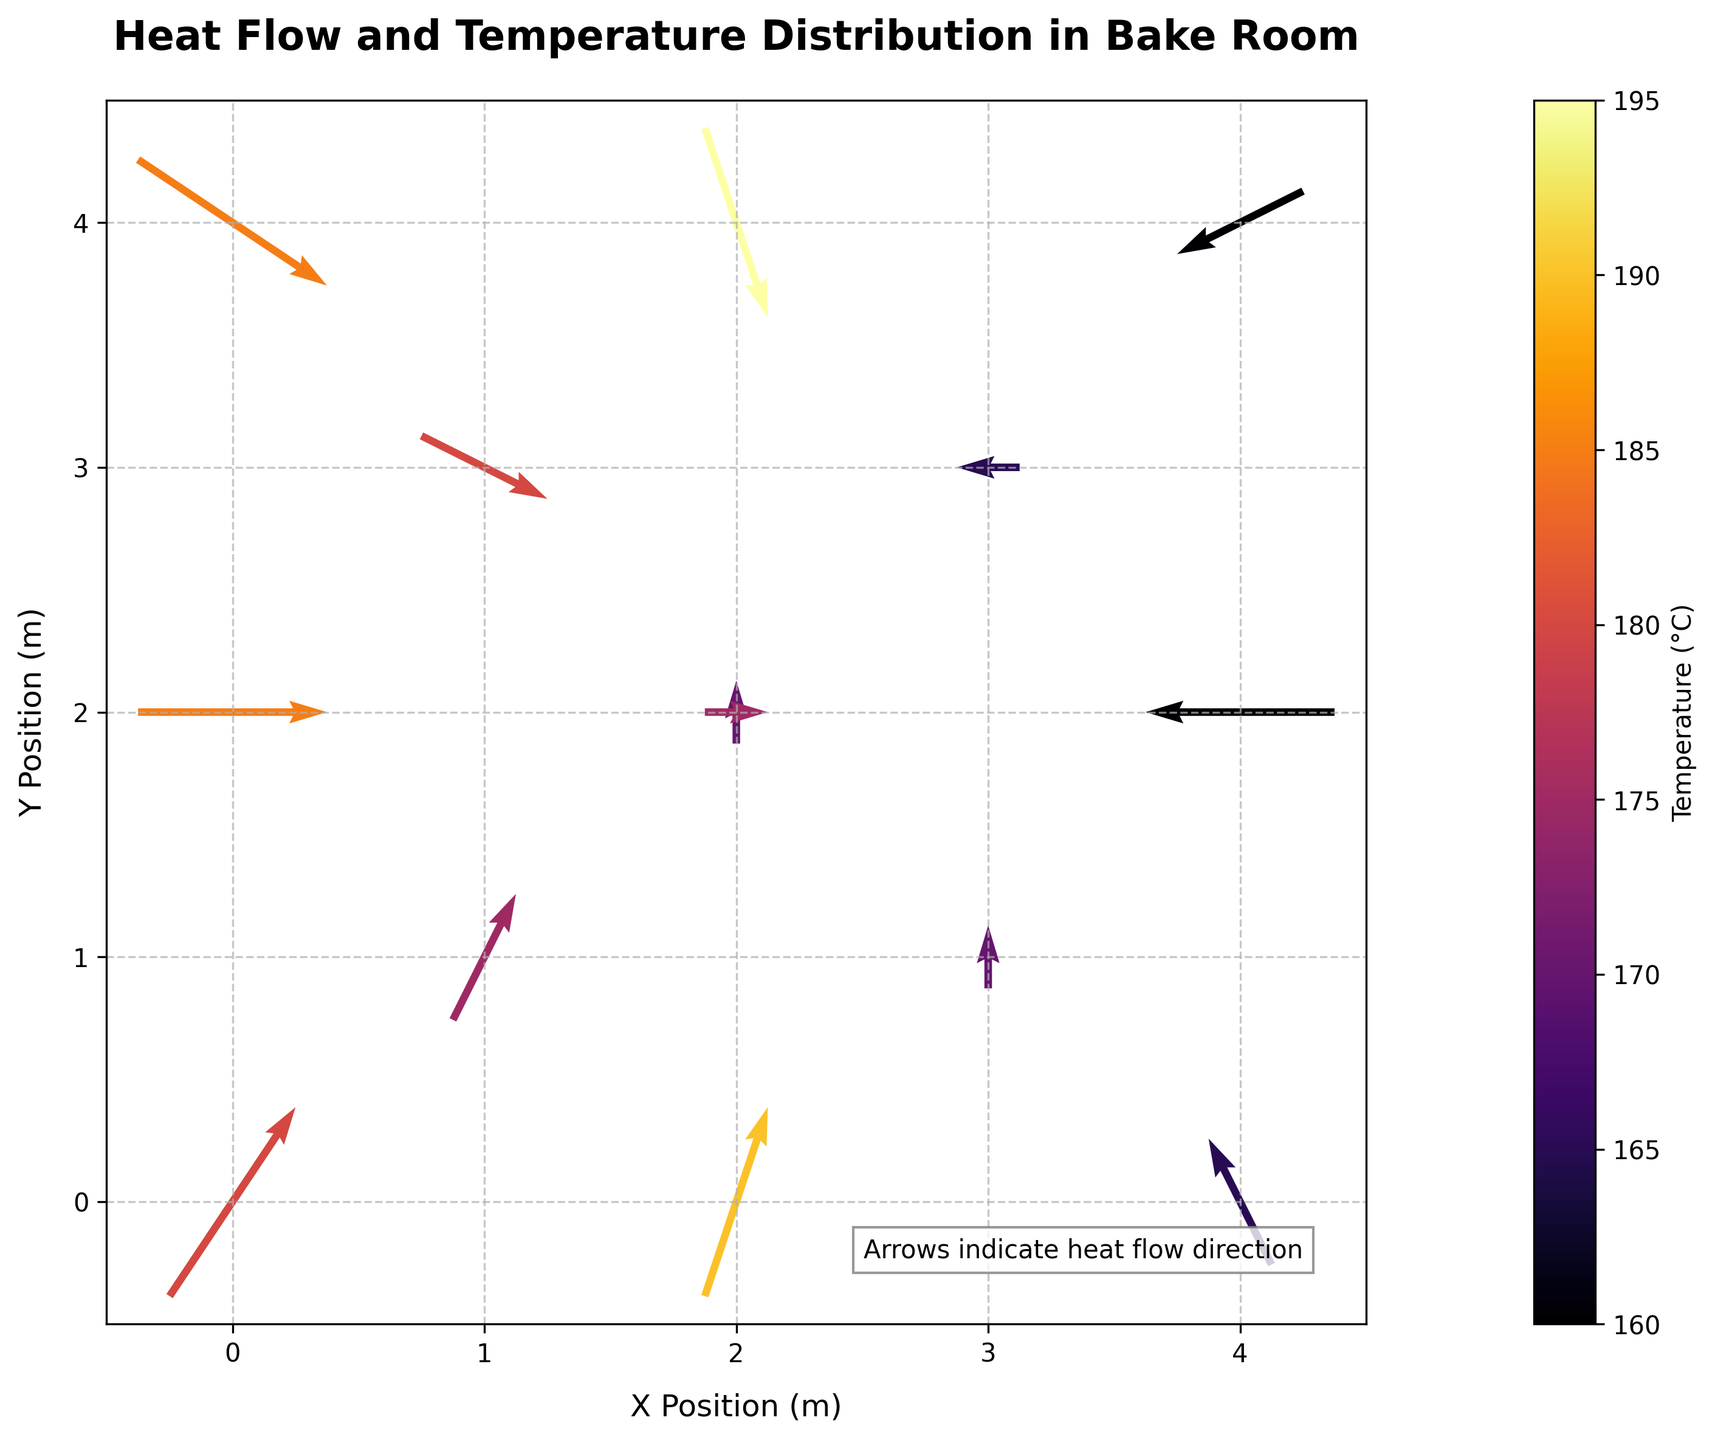what is the title of the plot? The title is printed at the top of the figure. By directly reading it, we can find the title.
Answer: Heat Flow and Temperature Distribution in Bake Room What is the x-axis label of the plot? The x-axis label is printed along the horizontal axis. By reading this area, we can identify the x-axis label.
Answer: X Position (m) What color represents the highest temperature range? By observing the color bar on the figure, we can see which color corresponds to the highest temperature range.
Answer: Light Yellow Where is the hottest point located in the bake room? The hottest point correlates with the lightest color (representing the highest temperature). By looking at the coordinates around the lightest color, we can determine the location.
Answer: At (2, 4) Does the air flow primarily upward or downward in the bake room? By observing the direction of the arrows in the quiver plot, we can determine the general direction of the airflow. If most arrows are pointing upwards, it indicates upward flow, and vice versa.
Answer: Upward Which position experiences the most significant downward airflow? To find the position with the most significant downward airflow, we need to identify the coordinates where the arrow's length extends the furthest downward direction (visible from arrow orientations).
Answer: (2,4) Is the temperature higher near the center or the edges of the bake room? By examining the color distribution across the quiver plot, we can compare the temperature in the center (middle of plot) to the edges (peripheral areas).
Answer: Center How does the air flow near the ovens tend to move? By looking at the arrows around the high-temperature areas (which represent the ovens), we can observe and conclude the air flow pattern near the ovens.
Answer: Upwards and outwards Which area has a lower temperature: the top right or bottom left of the bake room? By comparing the color (temperature) near the top right corner of the bake room to the bottom left corner, we can figure out which is lower.
Answer: Bottom left What is the general trend of temperature from the bottom to the top of the bake room? By examining the color gradient from the bottom to the top in the plot, we can see if the temperature increases or decreases.
Answer: Decreases 